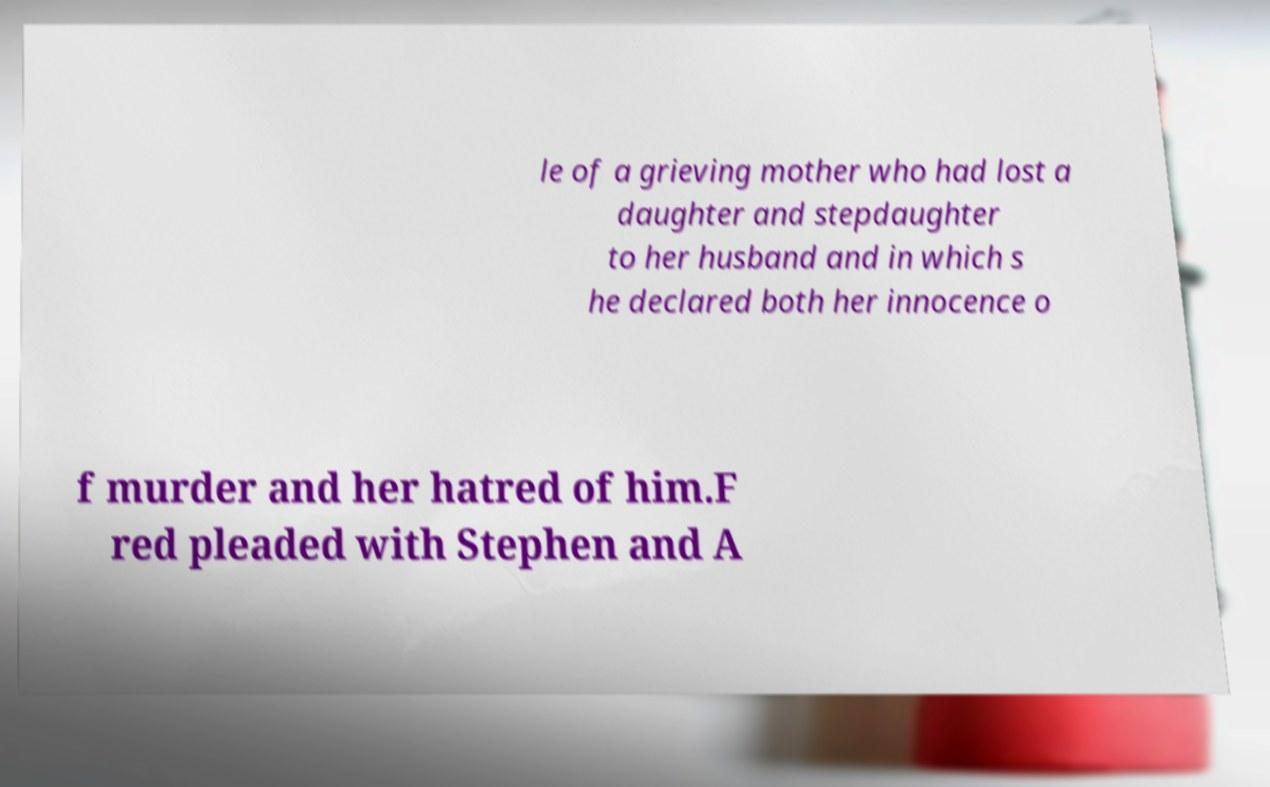Could you assist in decoding the text presented in this image and type it out clearly? le of a grieving mother who had lost a daughter and stepdaughter to her husband and in which s he declared both her innocence o f murder and her hatred of him.F red pleaded with Stephen and A 